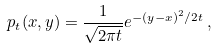<formula> <loc_0><loc_0><loc_500><loc_500>p _ { t } ( x , y ) = \frac { 1 } { \sqrt { 2 \pi t } } e ^ { - ( y - x ) ^ { 2 } / 2 t } \, ,</formula> 